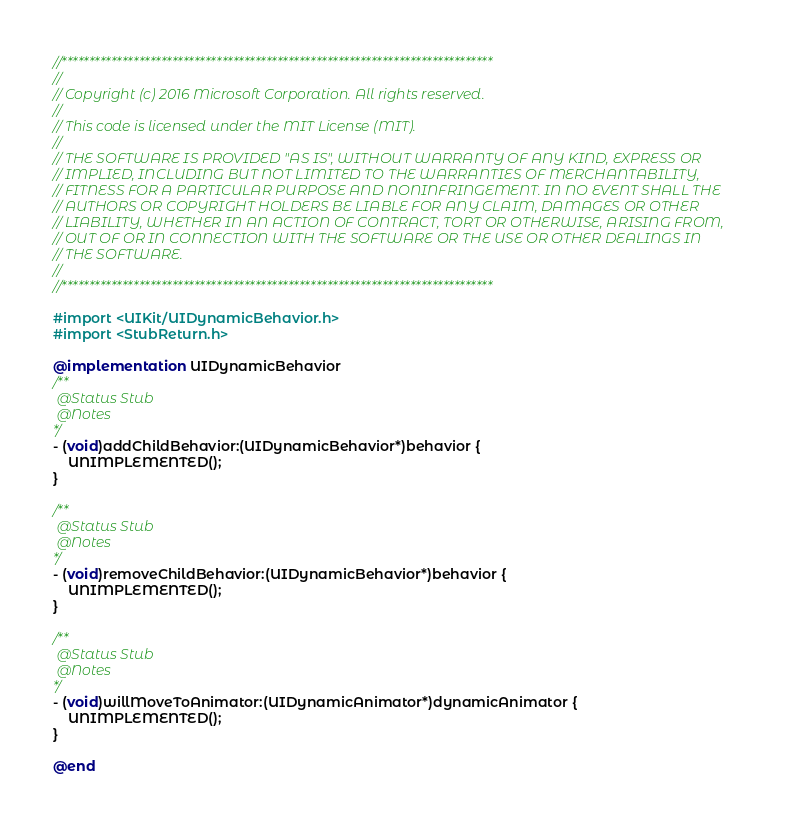Convert code to text. <code><loc_0><loc_0><loc_500><loc_500><_ObjectiveC_>//******************************************************************************
//
// Copyright (c) 2016 Microsoft Corporation. All rights reserved.
//
// This code is licensed under the MIT License (MIT).
//
// THE SOFTWARE IS PROVIDED "AS IS", WITHOUT WARRANTY OF ANY KIND, EXPRESS OR
// IMPLIED, INCLUDING BUT NOT LIMITED TO THE WARRANTIES OF MERCHANTABILITY,
// FITNESS FOR A PARTICULAR PURPOSE AND NONINFRINGEMENT. IN NO EVENT SHALL THE
// AUTHORS OR COPYRIGHT HOLDERS BE LIABLE FOR ANY CLAIM, DAMAGES OR OTHER
// LIABILITY, WHETHER IN AN ACTION OF CONTRACT, TORT OR OTHERWISE, ARISING FROM,
// OUT OF OR IN CONNECTION WITH THE SOFTWARE OR THE USE OR OTHER DEALINGS IN
// THE SOFTWARE.
//
//******************************************************************************

#import <UIKit/UIDynamicBehavior.h>
#import <StubReturn.h>

@implementation UIDynamicBehavior
/**
 @Status Stub
 @Notes
*/
- (void)addChildBehavior:(UIDynamicBehavior*)behavior {
    UNIMPLEMENTED();
}

/**
 @Status Stub
 @Notes
*/
- (void)removeChildBehavior:(UIDynamicBehavior*)behavior {
    UNIMPLEMENTED();
}

/**
 @Status Stub
 @Notes
*/
- (void)willMoveToAnimator:(UIDynamicAnimator*)dynamicAnimator {
    UNIMPLEMENTED();
}

@end
</code> 